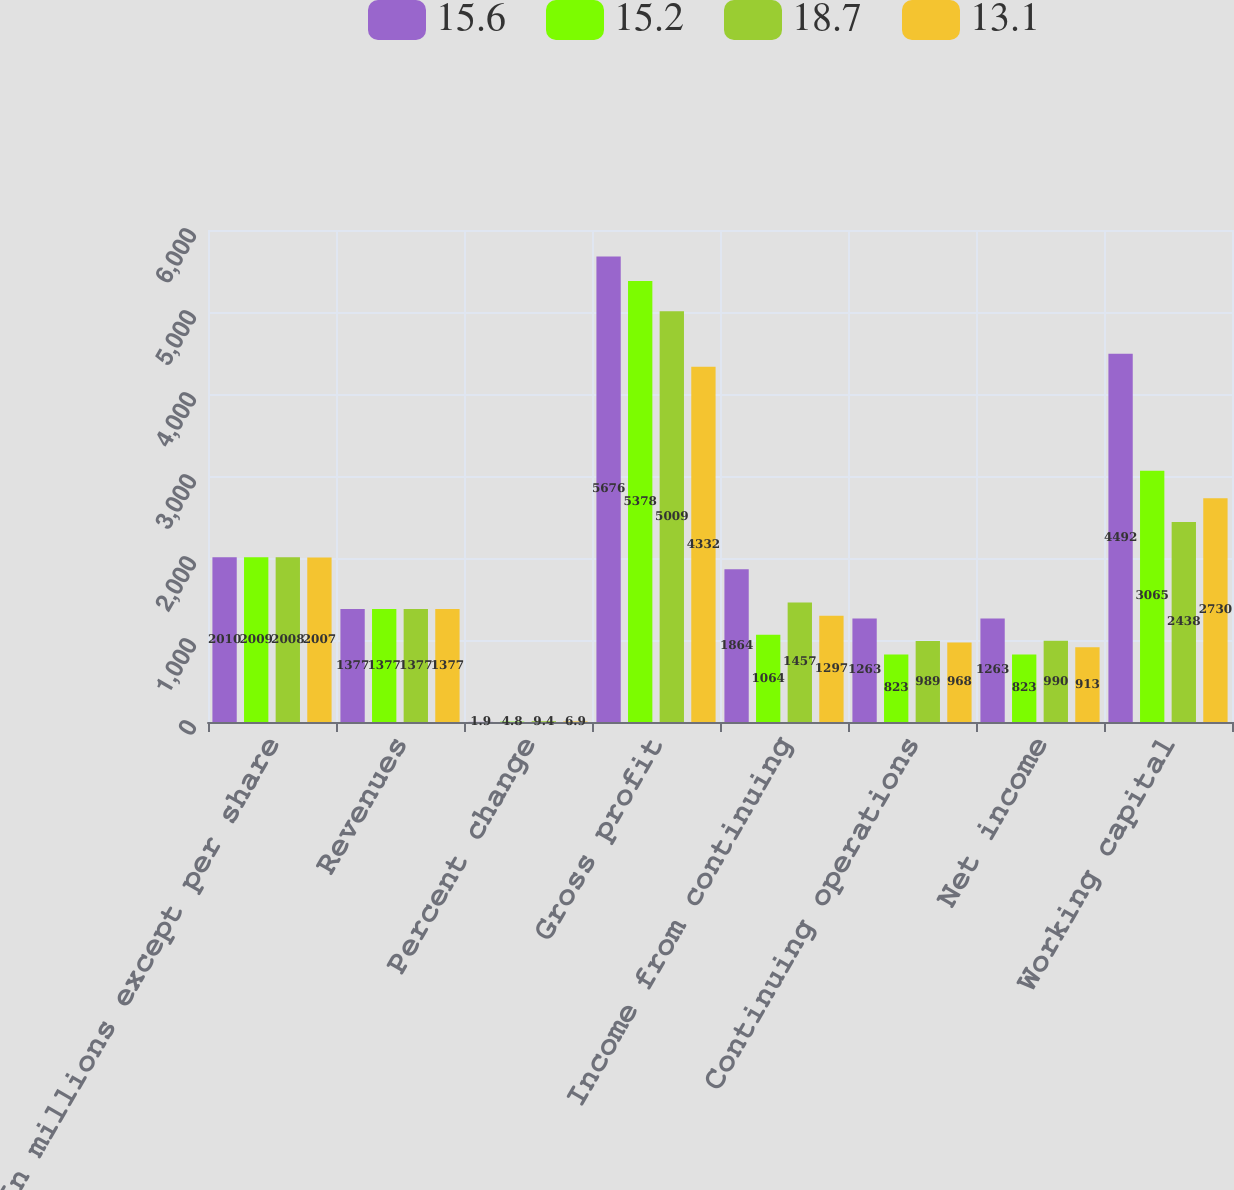Convert chart. <chart><loc_0><loc_0><loc_500><loc_500><stacked_bar_chart><ecel><fcel>(In millions except per share<fcel>Revenues<fcel>Percent change<fcel>Gross profit<fcel>Income from continuing<fcel>Continuing operations<fcel>Net income<fcel>Working capital<nl><fcel>15.6<fcel>2010<fcel>1377<fcel>1.9<fcel>5676<fcel>1864<fcel>1263<fcel>1263<fcel>4492<nl><fcel>15.2<fcel>2009<fcel>1377<fcel>4.8<fcel>5378<fcel>1064<fcel>823<fcel>823<fcel>3065<nl><fcel>18.7<fcel>2008<fcel>1377<fcel>9.4<fcel>5009<fcel>1457<fcel>989<fcel>990<fcel>2438<nl><fcel>13.1<fcel>2007<fcel>1377<fcel>6.9<fcel>4332<fcel>1297<fcel>968<fcel>913<fcel>2730<nl></chart> 